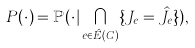<formula> <loc_0><loc_0><loc_500><loc_500>P ( \cdot ) = \mathbb { P } ( \cdot | \bigcap _ { e \in \hat { E } ( C ) } \{ J _ { e } = \hat { J } _ { e } \} ) ,</formula> 